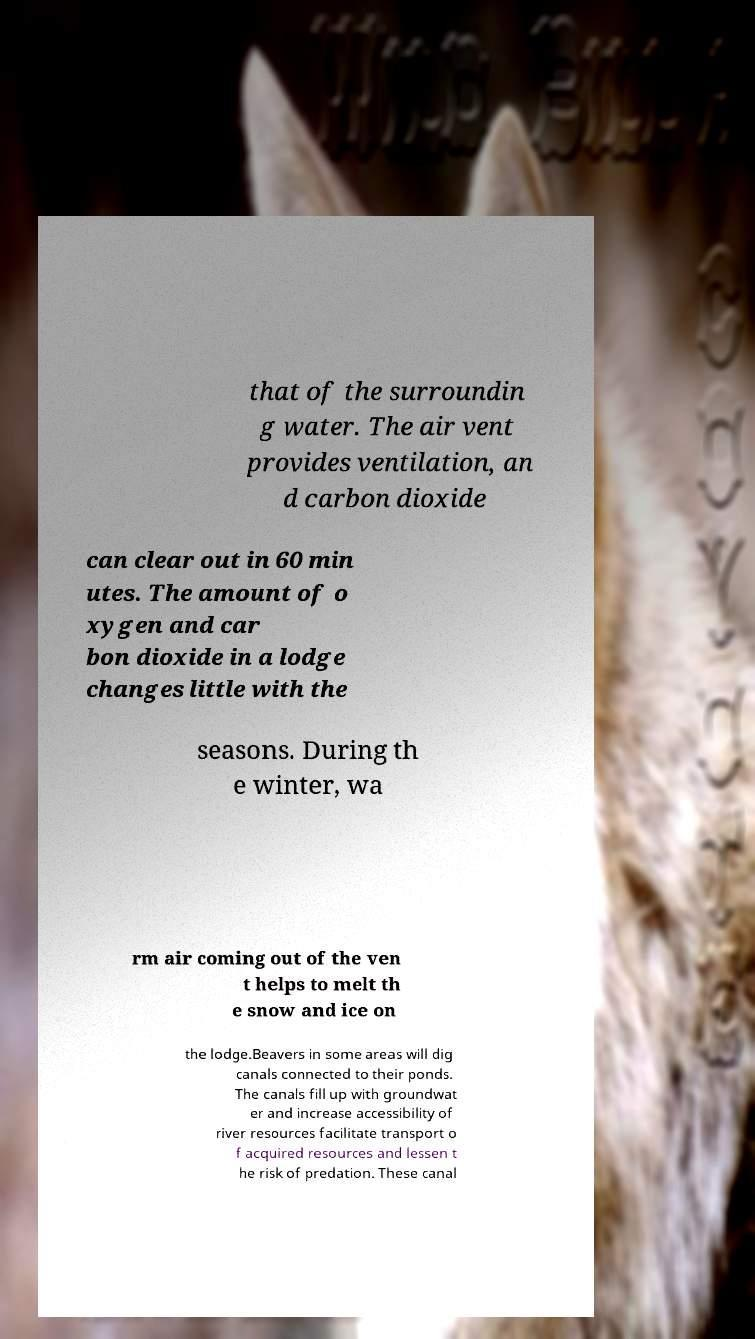Please identify and transcribe the text found in this image. that of the surroundin g water. The air vent provides ventilation, an d carbon dioxide can clear out in 60 min utes. The amount of o xygen and car bon dioxide in a lodge changes little with the seasons. During th e winter, wa rm air coming out of the ven t helps to melt th e snow and ice on the lodge.Beavers in some areas will dig canals connected to their ponds. The canals fill up with groundwat er and increase accessibility of river resources facilitate transport o f acquired resources and lessen t he risk of predation. These canal 